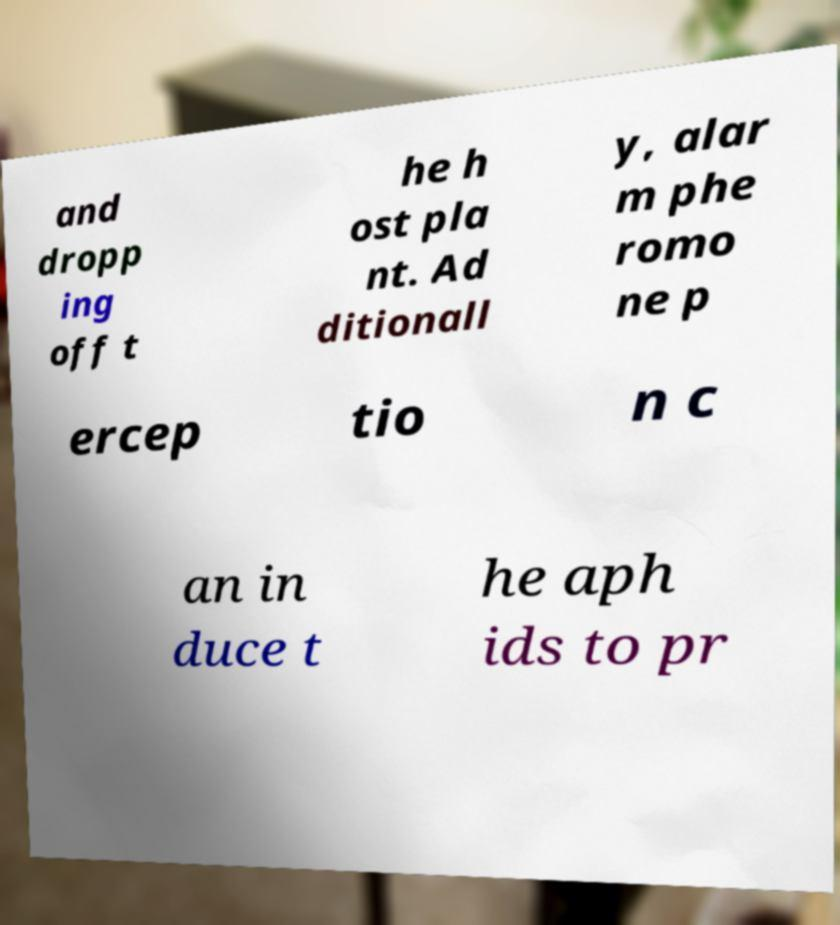Can you accurately transcribe the text from the provided image for me? and dropp ing off t he h ost pla nt. Ad ditionall y, alar m phe romo ne p ercep tio n c an in duce t he aph ids to pr 